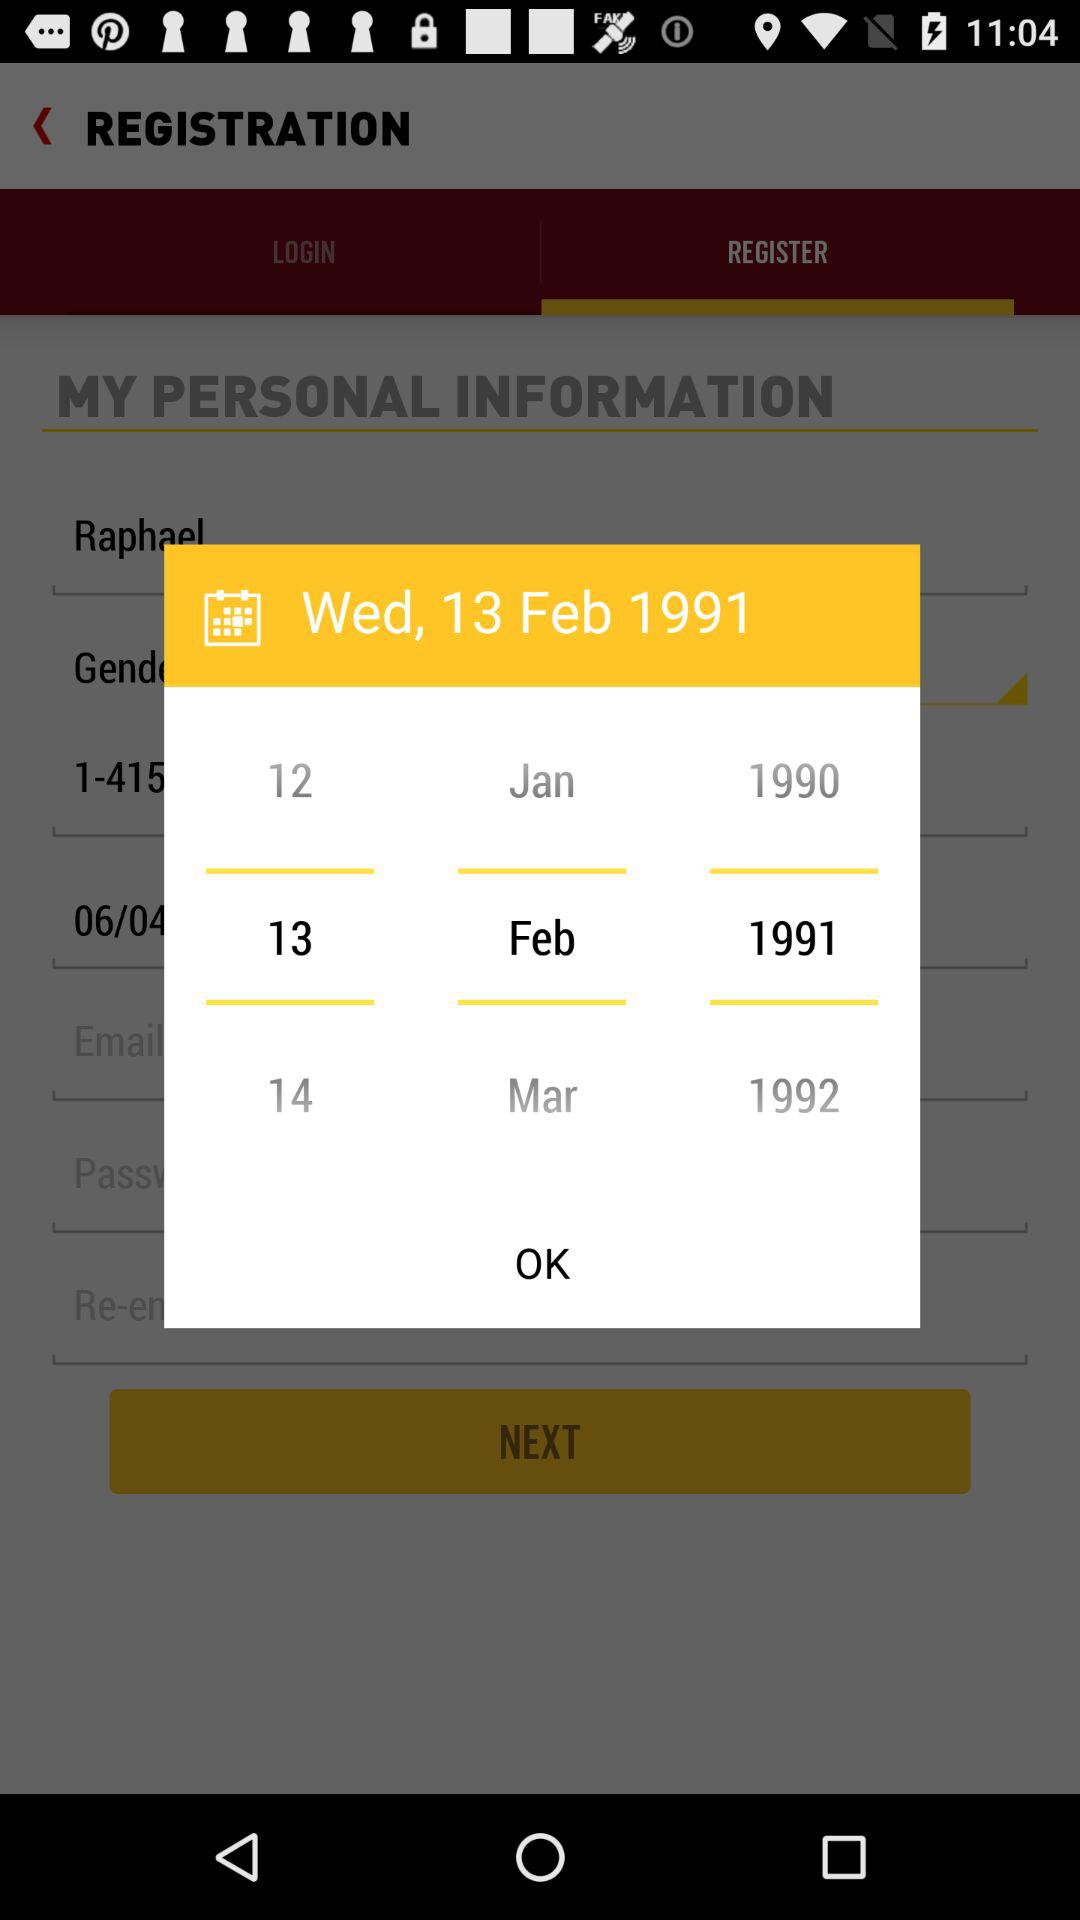Which is the selected date? The selected date is Wednesday, February 13, 1991. 